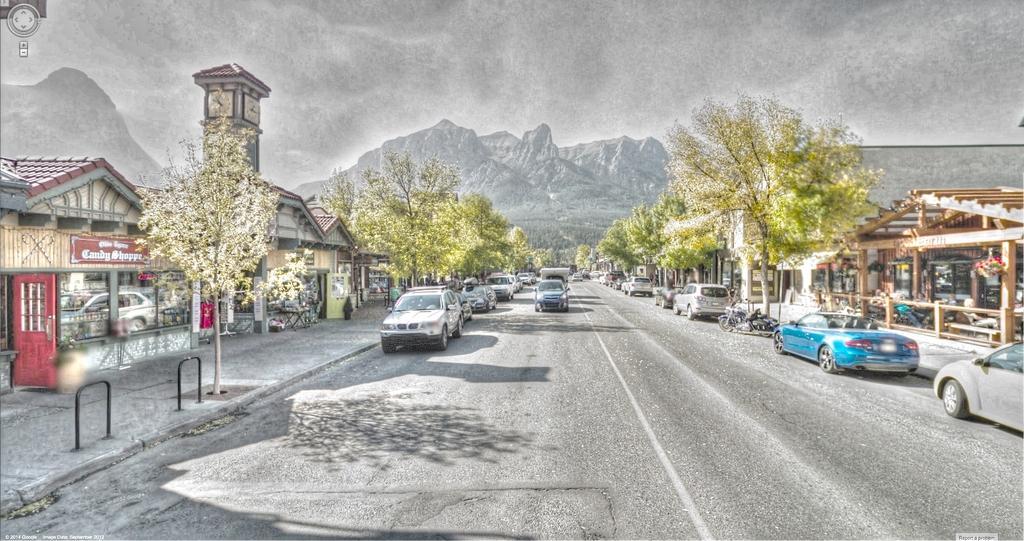Please provide a concise description of this image. In this picture there are shops, trees, and cars on the right and left side of the image, there is a clock tower in the image and there are mountains in the background area of the image. 